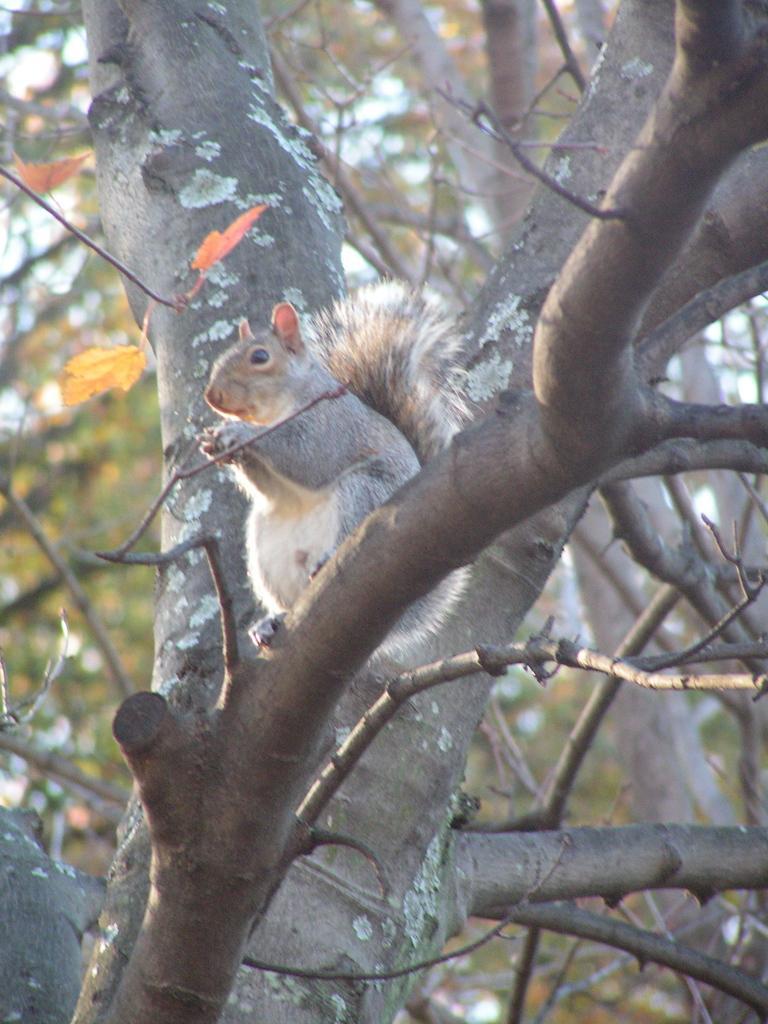How would you summarize this image in a sentence or two? There is a tree and a squirrel is sitting on the branch of a tree. 